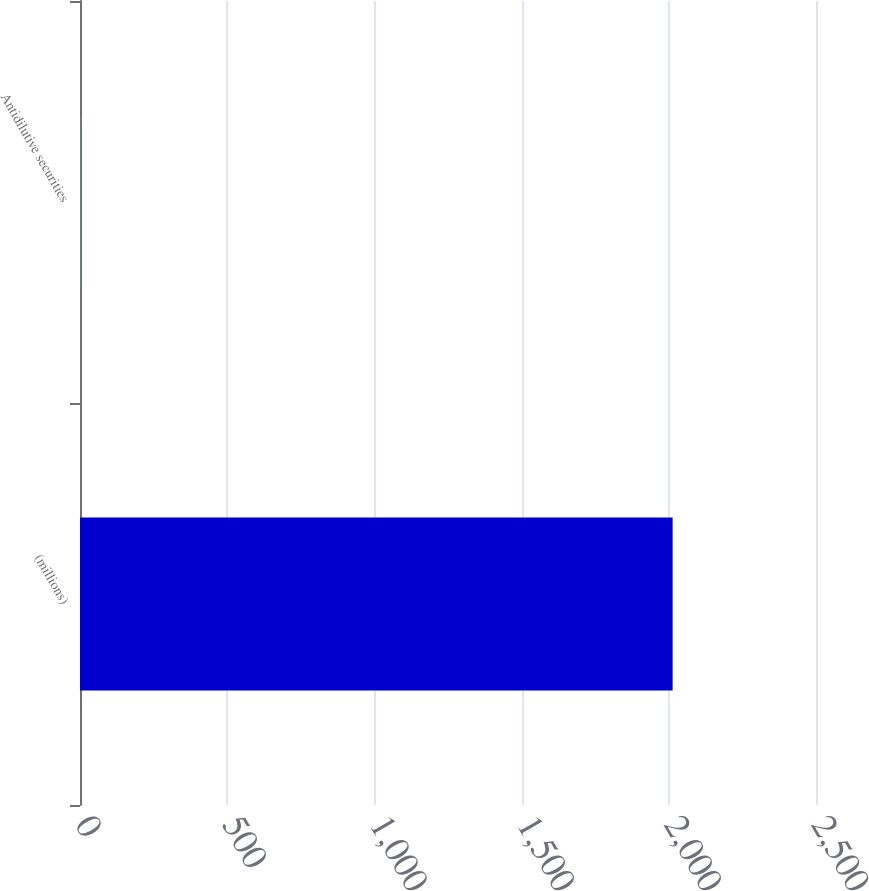<chart> <loc_0><loc_0><loc_500><loc_500><bar_chart><fcel>(millions)<fcel>Antidilutive securities<nl><fcel>2013<fcel>0.6<nl></chart> 